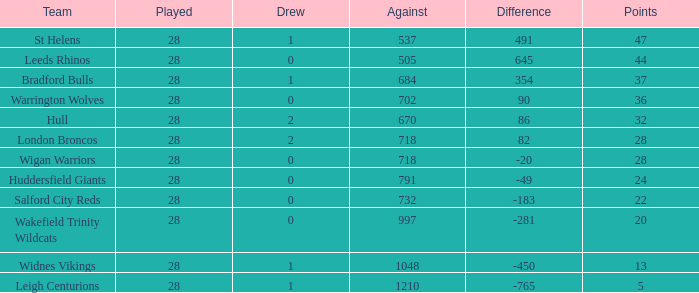What is the mean score for a team that has 4 losses and has participated in over 28 matches? None. 